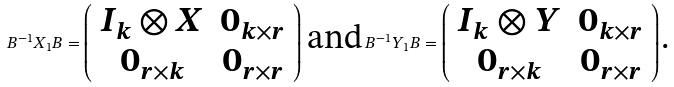<formula> <loc_0><loc_0><loc_500><loc_500>B ^ { - 1 } X _ { 1 } B = \left ( \begin{array} { c c } I _ { k } \otimes X & 0 _ { k \times r } \\ 0 _ { r \times k } & 0 _ { r \times r } \end{array} \right ) \, \text {and} \, B ^ { - 1 } Y _ { 1 } B = \left ( \begin{array} { c c } I _ { k } \otimes Y & 0 _ { k \times r } \\ 0 _ { r \times k } & 0 _ { r \times r } \end{array} \right ) \text {.}</formula> 